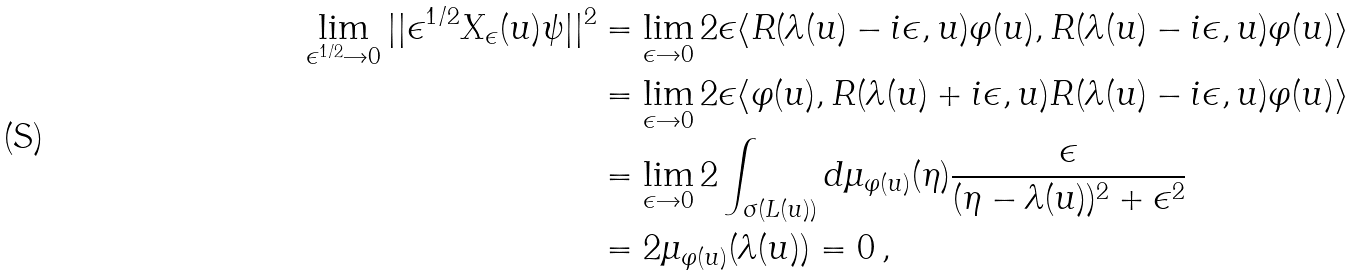Convert formula to latex. <formula><loc_0><loc_0><loc_500><loc_500>\lim _ { \epsilon ^ { 1 / 2 } \rightarrow 0 } | | \epsilon ^ { 1 / 2 } X _ { \epsilon } ( u ) \psi | | ^ { 2 } & = \lim _ { \epsilon \rightarrow 0 } 2 \epsilon \langle R ( \lambda ( u ) - i \epsilon , u ) \varphi ( u ) , R ( \lambda ( u ) - i \epsilon , u ) \varphi ( u ) \rangle \\ & = \lim _ { \epsilon \rightarrow 0 } 2 \epsilon \langle \varphi ( u ) , R ( \lambda ( u ) + i \epsilon , u ) R ( \lambda ( u ) - i \epsilon , u ) \varphi ( u ) \rangle \\ & = \lim _ { \epsilon \rightarrow 0 } 2 \int _ { \sigma ( L ( u ) ) } d \mu _ { \varphi ( u ) } ( \eta ) \frac { \epsilon } { ( \eta - \lambda ( u ) ) ^ { 2 } + \epsilon ^ { 2 } } \\ & = 2 \mu _ { \varphi ( u ) } ( \lambda ( u ) ) = 0 \, ,</formula> 